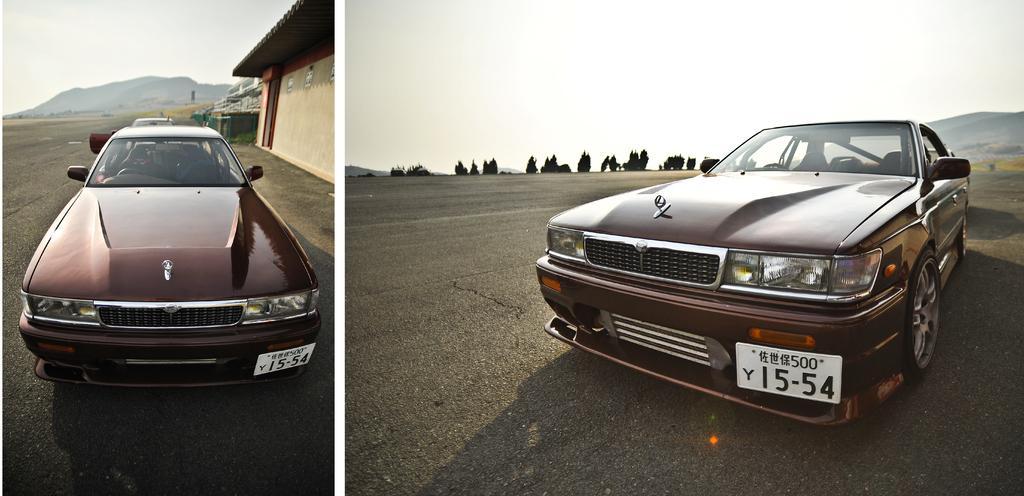Please provide a concise description of this image. Here we can see collage of two picture, on the left side picture we can see a car, a house, a hill and the sky, on the right side picture we can see a car in the front, in the background there are some trees, we can see the sky at the top of the picture. 